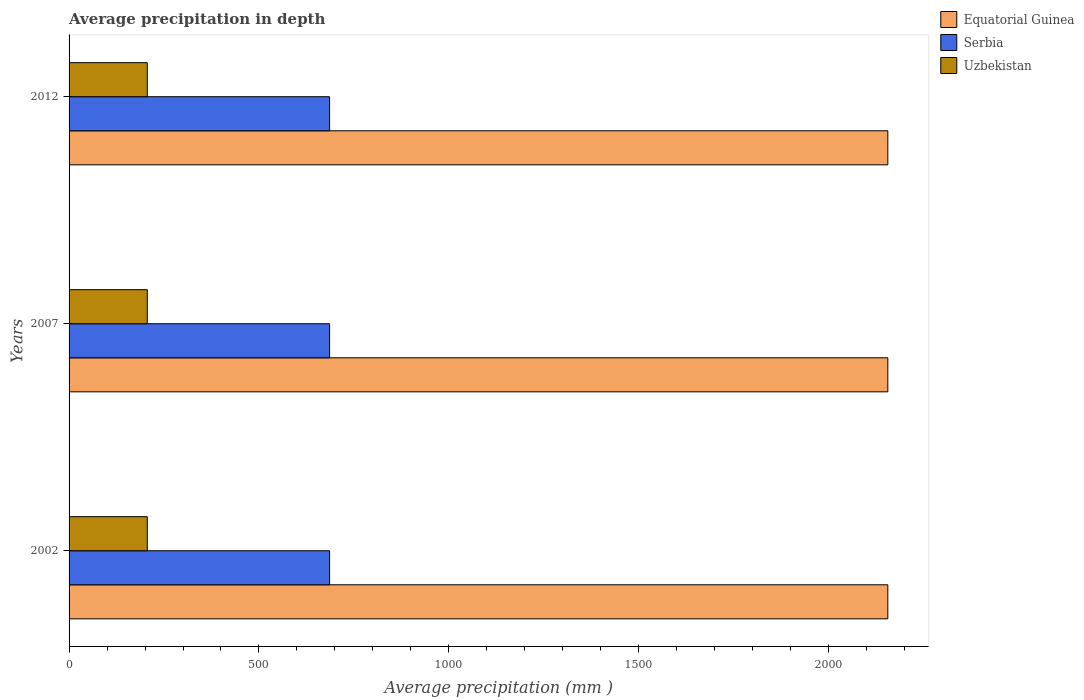Are the number of bars per tick equal to the number of legend labels?
Your response must be concise. Yes. What is the average precipitation in Equatorial Guinea in 2012?
Your answer should be very brief. 2156. Across all years, what is the maximum average precipitation in Serbia?
Your answer should be very brief. 686. Across all years, what is the minimum average precipitation in Equatorial Guinea?
Keep it short and to the point. 2156. In which year was the average precipitation in Equatorial Guinea minimum?
Give a very brief answer. 2002. What is the total average precipitation in Serbia in the graph?
Offer a terse response. 2058. What is the difference between the average precipitation in Equatorial Guinea in 2002 and that in 2007?
Keep it short and to the point. 0. What is the difference between the average precipitation in Uzbekistan in 2007 and the average precipitation in Equatorial Guinea in 2002?
Ensure brevity in your answer.  -1950. What is the average average precipitation in Serbia per year?
Ensure brevity in your answer.  686. In the year 2012, what is the difference between the average precipitation in Serbia and average precipitation in Uzbekistan?
Ensure brevity in your answer.  480. In how many years, is the average precipitation in Serbia greater than 600 mm?
Your answer should be compact. 3. What is the ratio of the average precipitation in Serbia in 2002 to that in 2012?
Make the answer very short. 1. What is the difference between the highest and the second highest average precipitation in Uzbekistan?
Offer a very short reply. 0. What does the 2nd bar from the top in 2002 represents?
Provide a short and direct response. Serbia. What does the 3rd bar from the bottom in 2002 represents?
Your answer should be compact. Uzbekistan. Is it the case that in every year, the sum of the average precipitation in Serbia and average precipitation in Uzbekistan is greater than the average precipitation in Equatorial Guinea?
Offer a terse response. No. What is the difference between two consecutive major ticks on the X-axis?
Your answer should be compact. 500. Are the values on the major ticks of X-axis written in scientific E-notation?
Ensure brevity in your answer.  No. Does the graph contain any zero values?
Give a very brief answer. No. How many legend labels are there?
Offer a very short reply. 3. How are the legend labels stacked?
Your response must be concise. Vertical. What is the title of the graph?
Your answer should be compact. Average precipitation in depth. Does "Ukraine" appear as one of the legend labels in the graph?
Provide a short and direct response. No. What is the label or title of the X-axis?
Provide a short and direct response. Average precipitation (mm ). What is the label or title of the Y-axis?
Your answer should be compact. Years. What is the Average precipitation (mm ) of Equatorial Guinea in 2002?
Provide a succinct answer. 2156. What is the Average precipitation (mm ) in Serbia in 2002?
Provide a short and direct response. 686. What is the Average precipitation (mm ) of Uzbekistan in 2002?
Keep it short and to the point. 206. What is the Average precipitation (mm ) in Equatorial Guinea in 2007?
Your answer should be very brief. 2156. What is the Average precipitation (mm ) in Serbia in 2007?
Your response must be concise. 686. What is the Average precipitation (mm ) in Uzbekistan in 2007?
Your answer should be very brief. 206. What is the Average precipitation (mm ) in Equatorial Guinea in 2012?
Provide a succinct answer. 2156. What is the Average precipitation (mm ) of Serbia in 2012?
Keep it short and to the point. 686. What is the Average precipitation (mm ) in Uzbekistan in 2012?
Your answer should be compact. 206. Across all years, what is the maximum Average precipitation (mm ) in Equatorial Guinea?
Provide a short and direct response. 2156. Across all years, what is the maximum Average precipitation (mm ) of Serbia?
Offer a terse response. 686. Across all years, what is the maximum Average precipitation (mm ) of Uzbekistan?
Provide a succinct answer. 206. Across all years, what is the minimum Average precipitation (mm ) in Equatorial Guinea?
Keep it short and to the point. 2156. Across all years, what is the minimum Average precipitation (mm ) in Serbia?
Offer a very short reply. 686. Across all years, what is the minimum Average precipitation (mm ) in Uzbekistan?
Offer a terse response. 206. What is the total Average precipitation (mm ) in Equatorial Guinea in the graph?
Keep it short and to the point. 6468. What is the total Average precipitation (mm ) of Serbia in the graph?
Offer a very short reply. 2058. What is the total Average precipitation (mm ) of Uzbekistan in the graph?
Provide a succinct answer. 618. What is the difference between the Average precipitation (mm ) in Uzbekistan in 2002 and that in 2007?
Your answer should be compact. 0. What is the difference between the Average precipitation (mm ) of Equatorial Guinea in 2002 and that in 2012?
Your answer should be compact. 0. What is the difference between the Average precipitation (mm ) in Serbia in 2007 and that in 2012?
Ensure brevity in your answer.  0. What is the difference between the Average precipitation (mm ) of Equatorial Guinea in 2002 and the Average precipitation (mm ) of Serbia in 2007?
Keep it short and to the point. 1470. What is the difference between the Average precipitation (mm ) of Equatorial Guinea in 2002 and the Average precipitation (mm ) of Uzbekistan in 2007?
Ensure brevity in your answer.  1950. What is the difference between the Average precipitation (mm ) in Serbia in 2002 and the Average precipitation (mm ) in Uzbekistan in 2007?
Your answer should be very brief. 480. What is the difference between the Average precipitation (mm ) in Equatorial Guinea in 2002 and the Average precipitation (mm ) in Serbia in 2012?
Give a very brief answer. 1470. What is the difference between the Average precipitation (mm ) in Equatorial Guinea in 2002 and the Average precipitation (mm ) in Uzbekistan in 2012?
Make the answer very short. 1950. What is the difference between the Average precipitation (mm ) in Serbia in 2002 and the Average precipitation (mm ) in Uzbekistan in 2012?
Ensure brevity in your answer.  480. What is the difference between the Average precipitation (mm ) in Equatorial Guinea in 2007 and the Average precipitation (mm ) in Serbia in 2012?
Your response must be concise. 1470. What is the difference between the Average precipitation (mm ) of Equatorial Guinea in 2007 and the Average precipitation (mm ) of Uzbekistan in 2012?
Your response must be concise. 1950. What is the difference between the Average precipitation (mm ) in Serbia in 2007 and the Average precipitation (mm ) in Uzbekistan in 2012?
Ensure brevity in your answer.  480. What is the average Average precipitation (mm ) in Equatorial Guinea per year?
Offer a very short reply. 2156. What is the average Average precipitation (mm ) in Serbia per year?
Your answer should be compact. 686. What is the average Average precipitation (mm ) in Uzbekistan per year?
Keep it short and to the point. 206. In the year 2002, what is the difference between the Average precipitation (mm ) of Equatorial Guinea and Average precipitation (mm ) of Serbia?
Your answer should be very brief. 1470. In the year 2002, what is the difference between the Average precipitation (mm ) in Equatorial Guinea and Average precipitation (mm ) in Uzbekistan?
Offer a terse response. 1950. In the year 2002, what is the difference between the Average precipitation (mm ) in Serbia and Average precipitation (mm ) in Uzbekistan?
Your answer should be compact. 480. In the year 2007, what is the difference between the Average precipitation (mm ) in Equatorial Guinea and Average precipitation (mm ) in Serbia?
Give a very brief answer. 1470. In the year 2007, what is the difference between the Average precipitation (mm ) in Equatorial Guinea and Average precipitation (mm ) in Uzbekistan?
Provide a short and direct response. 1950. In the year 2007, what is the difference between the Average precipitation (mm ) of Serbia and Average precipitation (mm ) of Uzbekistan?
Ensure brevity in your answer.  480. In the year 2012, what is the difference between the Average precipitation (mm ) in Equatorial Guinea and Average precipitation (mm ) in Serbia?
Keep it short and to the point. 1470. In the year 2012, what is the difference between the Average precipitation (mm ) in Equatorial Guinea and Average precipitation (mm ) in Uzbekistan?
Ensure brevity in your answer.  1950. In the year 2012, what is the difference between the Average precipitation (mm ) in Serbia and Average precipitation (mm ) in Uzbekistan?
Offer a very short reply. 480. What is the ratio of the Average precipitation (mm ) in Serbia in 2002 to that in 2007?
Your answer should be compact. 1. What is the ratio of the Average precipitation (mm ) in Equatorial Guinea in 2002 to that in 2012?
Keep it short and to the point. 1. What is the ratio of the Average precipitation (mm ) in Uzbekistan in 2002 to that in 2012?
Give a very brief answer. 1. What is the ratio of the Average precipitation (mm ) of Equatorial Guinea in 2007 to that in 2012?
Your response must be concise. 1. What is the ratio of the Average precipitation (mm ) of Serbia in 2007 to that in 2012?
Your answer should be compact. 1. What is the ratio of the Average precipitation (mm ) in Uzbekistan in 2007 to that in 2012?
Your answer should be very brief. 1. What is the difference between the highest and the second highest Average precipitation (mm ) of Serbia?
Provide a short and direct response. 0. What is the difference between the highest and the lowest Average precipitation (mm ) in Equatorial Guinea?
Provide a succinct answer. 0. What is the difference between the highest and the lowest Average precipitation (mm ) in Serbia?
Provide a succinct answer. 0. What is the difference between the highest and the lowest Average precipitation (mm ) of Uzbekistan?
Provide a succinct answer. 0. 